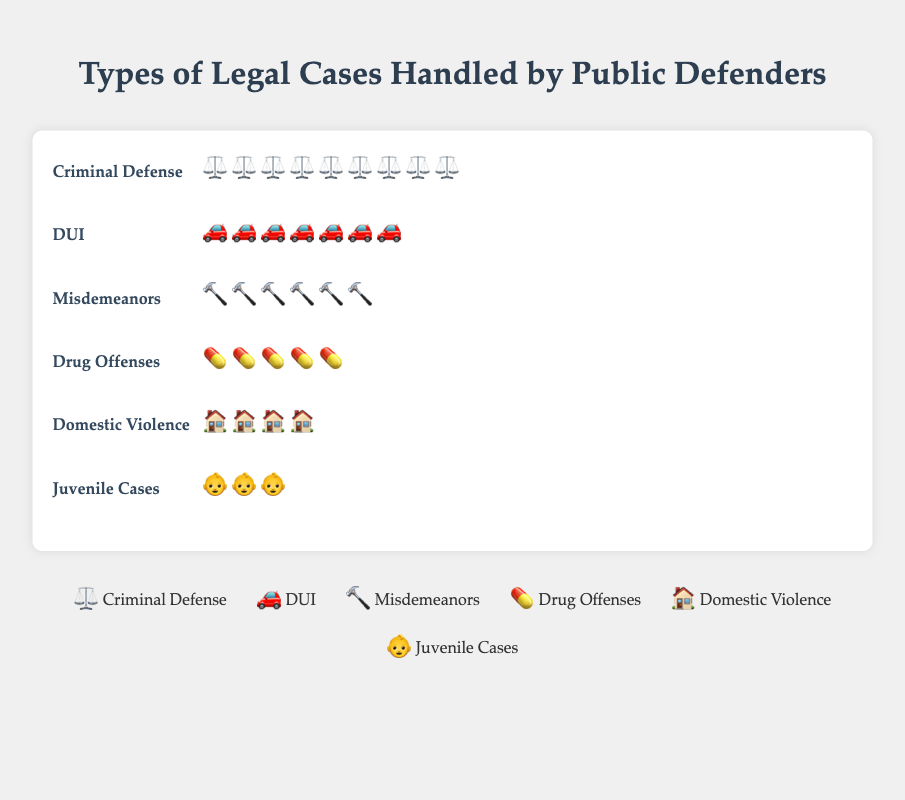What symbol is used for representing Criminal Defense cases? The symbol used for representing Criminal Defense cases is illustrated by the scales symbol.
Answer: scales How many cases of Domestic Violence are depicted in the figure? The case count for Domestic Violence is indicated in the data, and each case is shown with different symbols within the "Domestic Violence" category. Counting the symbols, we find that there are 20 symbols in the Domestic Violence row.
Answer: 20 What is the total number of cases for Drug Offenses and DUI combined? The data shows that there are 25 Drug Offense cases and 35 DUI cases. Adding these together gives 25 + 35 = 60.
Answer: 60 Which type of case has the least number of occurrences? By comparing the symbols for each case type, Juvenile Cases have the fewest with 15 symbols in total.
Answer: Juvenile Cases What is the difference in the number of cases between Criminal Defense and Misdemeanors? Criminal Defense has 45 cases and Misdemeanors have 30 cases. The difference is calculated as 45 - 30 = 15.
Answer: 15 How many more Criminal Defense cases are there compared to Drug Offenses? Criminal Defense cases are 45 and Drug Offenses are 25. The difference is 45 - 25 = 20.
Answer: 20 What percentage of the total cases does the DUI category represent? Total cases are: 45 (Criminal Defense) + 30 (Misdemeanors) + 15 (Juvenile Cases) + 25 (Drug Offenses) + 20 (Domestic Violence) + 35 (DUI) = 170. DUI cases are 35. The percentage for DUI is (35 / 170) * 100 ≈ 20.59%.
Answer: 20.59% Which case type uses the gavel symbol? The gavel symbol represents the Misdemeanors category in the figure.
Answer: Misdemeanors How many more Domestic Violence cases are there than Juvenile Cases? Domestic Violence cases are 20 and Juvenile Cases are 15. The difference is 20 - 15 = 5.
Answer: 5 